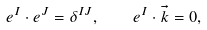Convert formula to latex. <formula><loc_0><loc_0><loc_500><loc_500>e ^ { I } \cdot e ^ { J } = \delta ^ { I J } , \quad e ^ { I } \cdot \vec { k } = 0 ,</formula> 